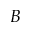<formula> <loc_0><loc_0><loc_500><loc_500>B</formula> 